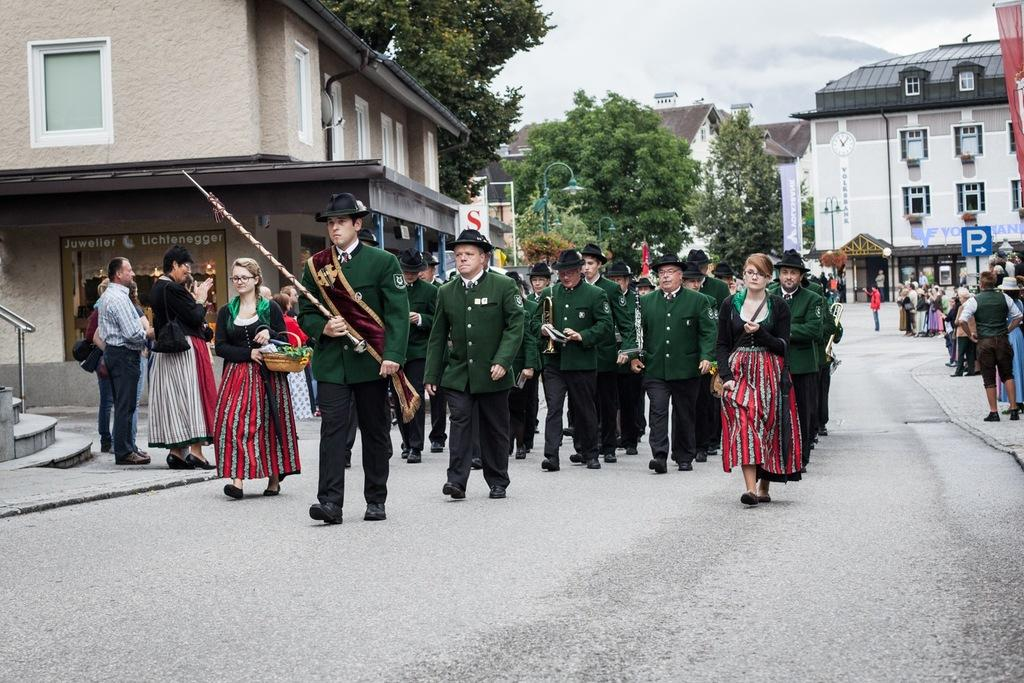What is happening with the group of men in the image? The men are walking on the road in the image. What are the men wearing in the image? The men are wearing green coats, green trousers, and green hats in the image. Who else is present in the image besides the group of men? There is a beautiful woman in the image. What is the woman doing in the image? The woman is walking in the image. What can be seen in the background of the image? There are houses and trees in the image. What type of note is the woman holding in the image? There is no note present in the image; the woman is simply walking. How many chairs can be seen in the image? There are no chairs visible in the image. 